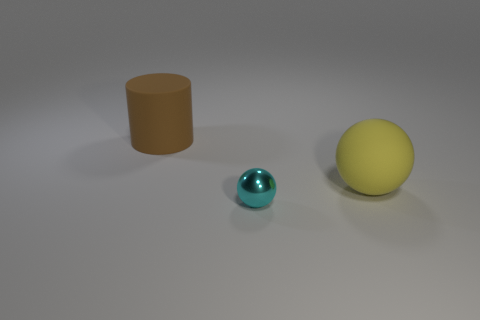Is there any other thing that is the same size as the cyan object?
Provide a short and direct response. No. What shape is the other big thing that is the same material as the large yellow object?
Your answer should be compact. Cylinder. Is there any other thing that has the same color as the cylinder?
Your response must be concise. No. There is a matte thing that is on the right side of the large rubber thing behind the yellow rubber thing; how many big brown cylinders are right of it?
Offer a terse response. 0. What number of yellow things are matte cylinders or balls?
Provide a short and direct response. 1. There is a cylinder; is it the same size as the rubber object right of the big brown matte object?
Provide a short and direct response. Yes. There is a large yellow object that is the same shape as the small thing; what material is it?
Ensure brevity in your answer.  Rubber. What number of other things are there of the same size as the metal thing?
Ensure brevity in your answer.  0. What shape is the matte object in front of the matte object that is on the left side of the large matte thing in front of the brown rubber object?
Your response must be concise. Sphere. What is the shape of the thing that is both on the right side of the cylinder and behind the small shiny object?
Ensure brevity in your answer.  Sphere. 